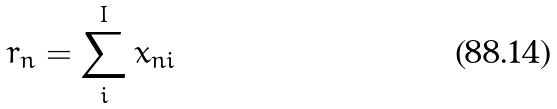Convert formula to latex. <formula><loc_0><loc_0><loc_500><loc_500>r _ { n } = \sum _ { i } ^ { I } x _ { n i }</formula> 